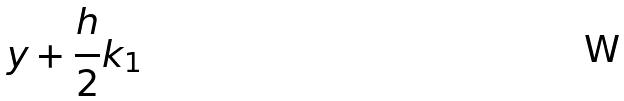Convert formula to latex. <formula><loc_0><loc_0><loc_500><loc_500>y + \frac { h } { 2 } k _ { 1 }</formula> 